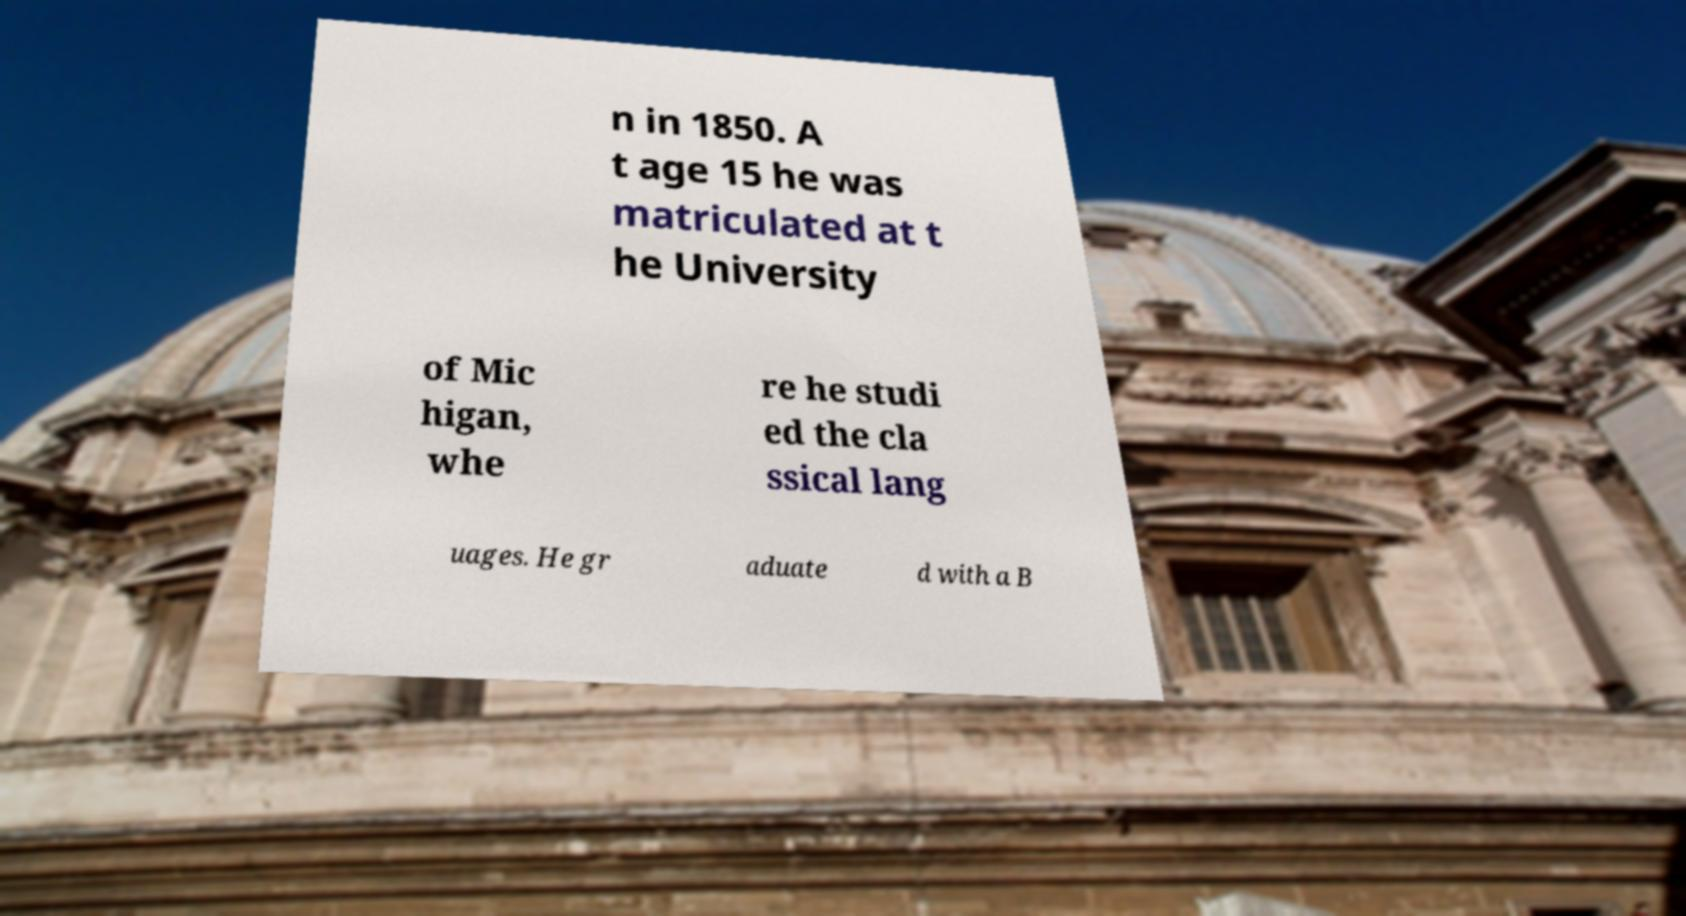Please read and relay the text visible in this image. What does it say? n in 1850. A t age 15 he was matriculated at t he University of Mic higan, whe re he studi ed the cla ssical lang uages. He gr aduate d with a B 